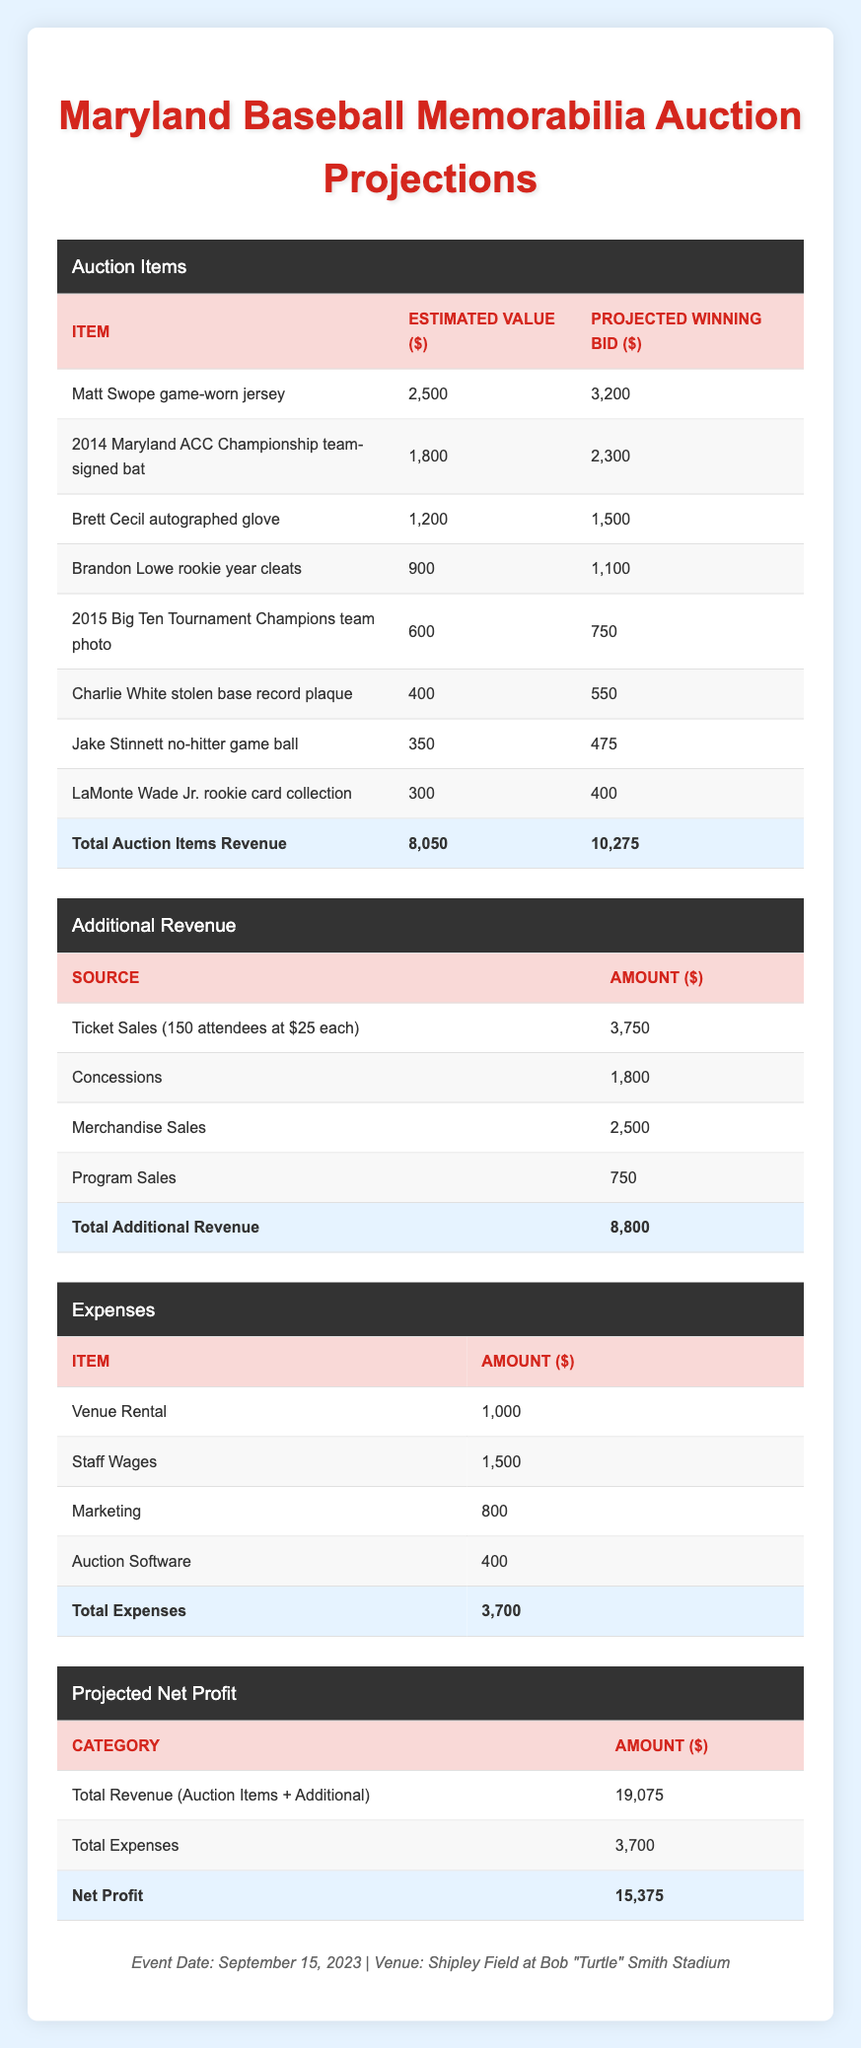What is the projected winning bid for the Matt Swope game-worn jersey? The table lists the projected winning bid for the Matt Swope game-worn jersey as 3,200 dollars.
Answer: 3,200 What is the total estimated value of all auction items? To find the total estimated value, sum the estimated values of all items: 2,500 + 1,800 + 1,200 + 900 + 600 + 400 + 350 + 300 = 8,050 dollars.
Answer: 8,050 Is the total additional revenue from ticket sales greater than the total revenue from auction items? The total additional revenue is 8,800 dollars from the additional revenue table, while the total revenue from auction items is 10,275 dollars. Since 8,800 is less than 10,275, the statement is false.
Answer: No What is the total net profit from the auction? The total net profit is calculated by subtracting total expenses (3,700) from the total revenue (19,075): 19,075 - 3,700 = 15,375 dollars.
Answer: 15,375 What is the difference between the projected winning bids of the 2014 Maryland ACC Championship team-signed bat and the LaMonte Wade Jr. rookie card collection? The projected winning bid for the team-signed bat is 2,300 dollars, and for the rookie card collection, it is 400 dollars. The difference is 2,300 - 400 = 1,900 dollars.
Answer: 1,900 How much are expenses for staff wages and marketing combined? The expenses for staff wages are 1,500 dollars and for marketing is 800 dollars. Adding these amounts together gives: 1,500 + 800 = 2,300 dollars.
Answer: 2,300 Is the estimated attendance for the auction greater than 200 people? The estimated attendance listed in the auction details is 150 people, so the statement is false since 150 is less than 200.
Answer: No What percentage of the total auction items revenue does the projected winning bid for the Brett Cecil autographed glove represent? The projected winning bid for the Brett Cecil autographed glove is 1,500 dollars. To find the percentage, divide 1,500 by the total auction items revenue (10,275) and multiply by 100: (1,500 / 10,275) * 100 = approximately 14.6 percent.
Answer: 14.6 percent What is the total revenue generated from merchandise sales and program sales? The revenue from merchandise sales is 2,500 dollars and from program sales is 750 dollars. Adding these amounts together gives: 2,500 + 750 = 3,250 dollars.
Answer: 3,250 